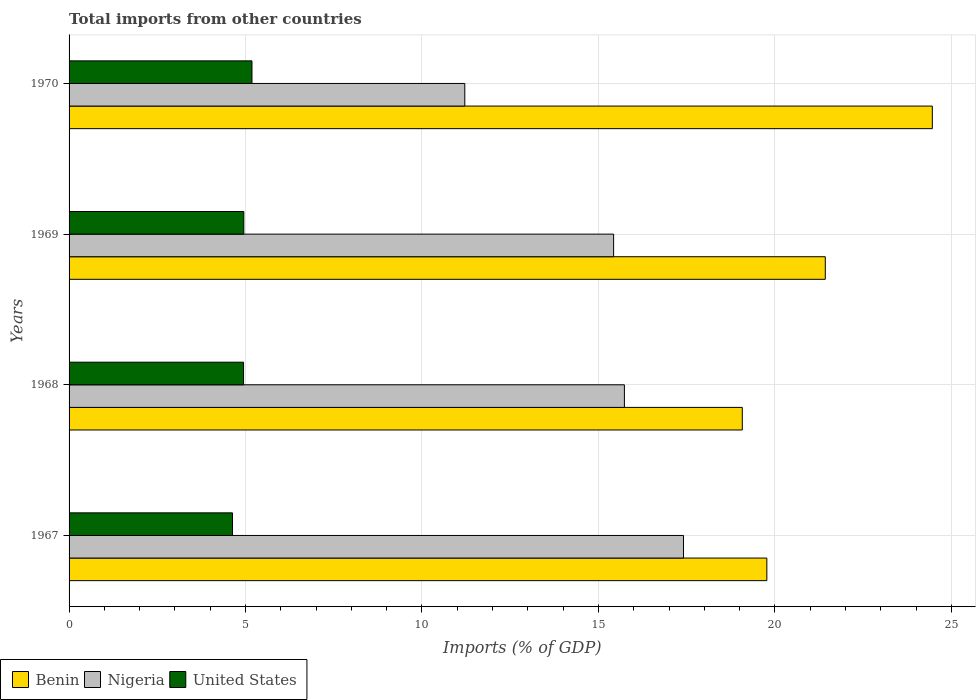How many different coloured bars are there?
Your answer should be compact. 3. How many groups of bars are there?
Offer a terse response. 4. Are the number of bars per tick equal to the number of legend labels?
Make the answer very short. Yes. What is the label of the 1st group of bars from the top?
Provide a short and direct response. 1970. What is the total imports in United States in 1968?
Offer a very short reply. 4.94. Across all years, what is the maximum total imports in Nigeria?
Your answer should be very brief. 17.41. Across all years, what is the minimum total imports in Nigeria?
Provide a short and direct response. 11.21. In which year was the total imports in Nigeria maximum?
Offer a very short reply. 1967. In which year was the total imports in United States minimum?
Offer a very short reply. 1967. What is the total total imports in Nigeria in the graph?
Offer a very short reply. 59.79. What is the difference between the total imports in Nigeria in 1968 and that in 1970?
Ensure brevity in your answer.  4.52. What is the difference between the total imports in United States in 1970 and the total imports in Nigeria in 1967?
Give a very brief answer. -12.23. What is the average total imports in United States per year?
Offer a terse response. 4.93. In the year 1967, what is the difference between the total imports in United States and total imports in Nigeria?
Your answer should be very brief. -12.78. In how many years, is the total imports in Benin greater than 9 %?
Your answer should be compact. 4. What is the ratio of the total imports in Benin in 1967 to that in 1969?
Make the answer very short. 0.92. What is the difference between the highest and the second highest total imports in Nigeria?
Provide a succinct answer. 1.67. What is the difference between the highest and the lowest total imports in Benin?
Your response must be concise. 5.38. Is the sum of the total imports in Benin in 1968 and 1969 greater than the maximum total imports in Nigeria across all years?
Provide a short and direct response. Yes. What does the 1st bar from the top in 1969 represents?
Your answer should be compact. United States. How many bars are there?
Provide a succinct answer. 12. How many years are there in the graph?
Your answer should be very brief. 4. Are the values on the major ticks of X-axis written in scientific E-notation?
Your response must be concise. No. Does the graph contain any zero values?
Ensure brevity in your answer.  No. Where does the legend appear in the graph?
Provide a short and direct response. Bottom left. How many legend labels are there?
Provide a short and direct response. 3. How are the legend labels stacked?
Ensure brevity in your answer.  Horizontal. What is the title of the graph?
Provide a short and direct response. Total imports from other countries. Does "Qatar" appear as one of the legend labels in the graph?
Keep it short and to the point. No. What is the label or title of the X-axis?
Your response must be concise. Imports (% of GDP). What is the label or title of the Y-axis?
Ensure brevity in your answer.  Years. What is the Imports (% of GDP) of Benin in 1967?
Ensure brevity in your answer.  19.77. What is the Imports (% of GDP) in Nigeria in 1967?
Make the answer very short. 17.41. What is the Imports (% of GDP) of United States in 1967?
Provide a succinct answer. 4.63. What is the Imports (% of GDP) in Benin in 1968?
Ensure brevity in your answer.  19.08. What is the Imports (% of GDP) in Nigeria in 1968?
Give a very brief answer. 15.74. What is the Imports (% of GDP) of United States in 1968?
Provide a short and direct response. 4.94. What is the Imports (% of GDP) in Benin in 1969?
Your answer should be compact. 21.43. What is the Imports (% of GDP) in Nigeria in 1969?
Provide a succinct answer. 15.43. What is the Imports (% of GDP) in United States in 1969?
Ensure brevity in your answer.  4.95. What is the Imports (% of GDP) in Benin in 1970?
Your answer should be very brief. 24.46. What is the Imports (% of GDP) of Nigeria in 1970?
Keep it short and to the point. 11.21. What is the Imports (% of GDP) in United States in 1970?
Your response must be concise. 5.18. Across all years, what is the maximum Imports (% of GDP) in Benin?
Your answer should be compact. 24.46. Across all years, what is the maximum Imports (% of GDP) of Nigeria?
Offer a very short reply. 17.41. Across all years, what is the maximum Imports (% of GDP) of United States?
Your answer should be compact. 5.18. Across all years, what is the minimum Imports (% of GDP) of Benin?
Make the answer very short. 19.08. Across all years, what is the minimum Imports (% of GDP) in Nigeria?
Give a very brief answer. 11.21. Across all years, what is the minimum Imports (% of GDP) in United States?
Your response must be concise. 4.63. What is the total Imports (% of GDP) of Benin in the graph?
Keep it short and to the point. 84.74. What is the total Imports (% of GDP) in Nigeria in the graph?
Provide a short and direct response. 59.79. What is the total Imports (% of GDP) in United States in the graph?
Your response must be concise. 19.71. What is the difference between the Imports (% of GDP) of Benin in 1967 and that in 1968?
Make the answer very short. 0.7. What is the difference between the Imports (% of GDP) of Nigeria in 1967 and that in 1968?
Provide a short and direct response. 1.67. What is the difference between the Imports (% of GDP) in United States in 1967 and that in 1968?
Your answer should be very brief. -0.31. What is the difference between the Imports (% of GDP) in Benin in 1967 and that in 1969?
Provide a short and direct response. -1.66. What is the difference between the Imports (% of GDP) in Nigeria in 1967 and that in 1969?
Offer a terse response. 1.98. What is the difference between the Imports (% of GDP) of United States in 1967 and that in 1969?
Provide a short and direct response. -0.32. What is the difference between the Imports (% of GDP) in Benin in 1967 and that in 1970?
Your response must be concise. -4.69. What is the difference between the Imports (% of GDP) in Nigeria in 1967 and that in 1970?
Your answer should be compact. 6.2. What is the difference between the Imports (% of GDP) of United States in 1967 and that in 1970?
Provide a short and direct response. -0.55. What is the difference between the Imports (% of GDP) in Benin in 1968 and that in 1969?
Your answer should be very brief. -2.35. What is the difference between the Imports (% of GDP) of Nigeria in 1968 and that in 1969?
Ensure brevity in your answer.  0.31. What is the difference between the Imports (% of GDP) of United States in 1968 and that in 1969?
Offer a terse response. -0.01. What is the difference between the Imports (% of GDP) of Benin in 1968 and that in 1970?
Offer a terse response. -5.38. What is the difference between the Imports (% of GDP) in Nigeria in 1968 and that in 1970?
Provide a short and direct response. 4.52. What is the difference between the Imports (% of GDP) of United States in 1968 and that in 1970?
Ensure brevity in your answer.  -0.24. What is the difference between the Imports (% of GDP) in Benin in 1969 and that in 1970?
Provide a succinct answer. -3.03. What is the difference between the Imports (% of GDP) in Nigeria in 1969 and that in 1970?
Ensure brevity in your answer.  4.22. What is the difference between the Imports (% of GDP) in United States in 1969 and that in 1970?
Your response must be concise. -0.23. What is the difference between the Imports (% of GDP) in Benin in 1967 and the Imports (% of GDP) in Nigeria in 1968?
Your response must be concise. 4.04. What is the difference between the Imports (% of GDP) of Benin in 1967 and the Imports (% of GDP) of United States in 1968?
Ensure brevity in your answer.  14.83. What is the difference between the Imports (% of GDP) in Nigeria in 1967 and the Imports (% of GDP) in United States in 1968?
Your answer should be compact. 12.47. What is the difference between the Imports (% of GDP) of Benin in 1967 and the Imports (% of GDP) of Nigeria in 1969?
Ensure brevity in your answer.  4.34. What is the difference between the Imports (% of GDP) in Benin in 1967 and the Imports (% of GDP) in United States in 1969?
Provide a succinct answer. 14.82. What is the difference between the Imports (% of GDP) in Nigeria in 1967 and the Imports (% of GDP) in United States in 1969?
Ensure brevity in your answer.  12.46. What is the difference between the Imports (% of GDP) of Benin in 1967 and the Imports (% of GDP) of Nigeria in 1970?
Offer a terse response. 8.56. What is the difference between the Imports (% of GDP) of Benin in 1967 and the Imports (% of GDP) of United States in 1970?
Your response must be concise. 14.59. What is the difference between the Imports (% of GDP) of Nigeria in 1967 and the Imports (% of GDP) of United States in 1970?
Provide a succinct answer. 12.23. What is the difference between the Imports (% of GDP) in Benin in 1968 and the Imports (% of GDP) in Nigeria in 1969?
Provide a short and direct response. 3.65. What is the difference between the Imports (% of GDP) of Benin in 1968 and the Imports (% of GDP) of United States in 1969?
Offer a very short reply. 14.13. What is the difference between the Imports (% of GDP) of Nigeria in 1968 and the Imports (% of GDP) of United States in 1969?
Offer a terse response. 10.78. What is the difference between the Imports (% of GDP) of Benin in 1968 and the Imports (% of GDP) of Nigeria in 1970?
Ensure brevity in your answer.  7.86. What is the difference between the Imports (% of GDP) in Benin in 1968 and the Imports (% of GDP) in United States in 1970?
Provide a short and direct response. 13.89. What is the difference between the Imports (% of GDP) of Nigeria in 1968 and the Imports (% of GDP) of United States in 1970?
Offer a terse response. 10.55. What is the difference between the Imports (% of GDP) in Benin in 1969 and the Imports (% of GDP) in Nigeria in 1970?
Your answer should be very brief. 10.21. What is the difference between the Imports (% of GDP) in Benin in 1969 and the Imports (% of GDP) in United States in 1970?
Provide a short and direct response. 16.25. What is the difference between the Imports (% of GDP) in Nigeria in 1969 and the Imports (% of GDP) in United States in 1970?
Ensure brevity in your answer.  10.25. What is the average Imports (% of GDP) of Benin per year?
Give a very brief answer. 21.18. What is the average Imports (% of GDP) in Nigeria per year?
Keep it short and to the point. 14.95. What is the average Imports (% of GDP) of United States per year?
Ensure brevity in your answer.  4.93. In the year 1967, what is the difference between the Imports (% of GDP) in Benin and Imports (% of GDP) in Nigeria?
Offer a terse response. 2.36. In the year 1967, what is the difference between the Imports (% of GDP) of Benin and Imports (% of GDP) of United States?
Keep it short and to the point. 15.14. In the year 1967, what is the difference between the Imports (% of GDP) of Nigeria and Imports (% of GDP) of United States?
Your answer should be very brief. 12.78. In the year 1968, what is the difference between the Imports (% of GDP) in Benin and Imports (% of GDP) in Nigeria?
Keep it short and to the point. 3.34. In the year 1968, what is the difference between the Imports (% of GDP) of Benin and Imports (% of GDP) of United States?
Offer a very short reply. 14.13. In the year 1968, what is the difference between the Imports (% of GDP) in Nigeria and Imports (% of GDP) in United States?
Make the answer very short. 10.79. In the year 1969, what is the difference between the Imports (% of GDP) of Benin and Imports (% of GDP) of Nigeria?
Keep it short and to the point. 6. In the year 1969, what is the difference between the Imports (% of GDP) in Benin and Imports (% of GDP) in United States?
Ensure brevity in your answer.  16.48. In the year 1969, what is the difference between the Imports (% of GDP) of Nigeria and Imports (% of GDP) of United States?
Your response must be concise. 10.48. In the year 1970, what is the difference between the Imports (% of GDP) in Benin and Imports (% of GDP) in Nigeria?
Ensure brevity in your answer.  13.25. In the year 1970, what is the difference between the Imports (% of GDP) of Benin and Imports (% of GDP) of United States?
Keep it short and to the point. 19.28. In the year 1970, what is the difference between the Imports (% of GDP) of Nigeria and Imports (% of GDP) of United States?
Keep it short and to the point. 6.03. What is the ratio of the Imports (% of GDP) in Benin in 1967 to that in 1968?
Offer a terse response. 1.04. What is the ratio of the Imports (% of GDP) of Nigeria in 1967 to that in 1968?
Give a very brief answer. 1.11. What is the ratio of the Imports (% of GDP) of United States in 1967 to that in 1968?
Provide a short and direct response. 0.94. What is the ratio of the Imports (% of GDP) of Benin in 1967 to that in 1969?
Your answer should be very brief. 0.92. What is the ratio of the Imports (% of GDP) in Nigeria in 1967 to that in 1969?
Offer a very short reply. 1.13. What is the ratio of the Imports (% of GDP) in United States in 1967 to that in 1969?
Ensure brevity in your answer.  0.94. What is the ratio of the Imports (% of GDP) of Benin in 1967 to that in 1970?
Provide a short and direct response. 0.81. What is the ratio of the Imports (% of GDP) in Nigeria in 1967 to that in 1970?
Offer a very short reply. 1.55. What is the ratio of the Imports (% of GDP) in United States in 1967 to that in 1970?
Your answer should be compact. 0.89. What is the ratio of the Imports (% of GDP) of Benin in 1968 to that in 1969?
Your answer should be very brief. 0.89. What is the ratio of the Imports (% of GDP) of Nigeria in 1968 to that in 1969?
Offer a terse response. 1.02. What is the ratio of the Imports (% of GDP) in Benin in 1968 to that in 1970?
Ensure brevity in your answer.  0.78. What is the ratio of the Imports (% of GDP) in Nigeria in 1968 to that in 1970?
Ensure brevity in your answer.  1.4. What is the ratio of the Imports (% of GDP) of United States in 1968 to that in 1970?
Offer a terse response. 0.95. What is the ratio of the Imports (% of GDP) in Benin in 1969 to that in 1970?
Provide a short and direct response. 0.88. What is the ratio of the Imports (% of GDP) of Nigeria in 1969 to that in 1970?
Your response must be concise. 1.38. What is the ratio of the Imports (% of GDP) in United States in 1969 to that in 1970?
Offer a terse response. 0.96. What is the difference between the highest and the second highest Imports (% of GDP) in Benin?
Your response must be concise. 3.03. What is the difference between the highest and the second highest Imports (% of GDP) of Nigeria?
Your answer should be very brief. 1.67. What is the difference between the highest and the second highest Imports (% of GDP) in United States?
Offer a terse response. 0.23. What is the difference between the highest and the lowest Imports (% of GDP) in Benin?
Keep it short and to the point. 5.38. What is the difference between the highest and the lowest Imports (% of GDP) in Nigeria?
Your answer should be compact. 6.2. What is the difference between the highest and the lowest Imports (% of GDP) in United States?
Your answer should be very brief. 0.55. 